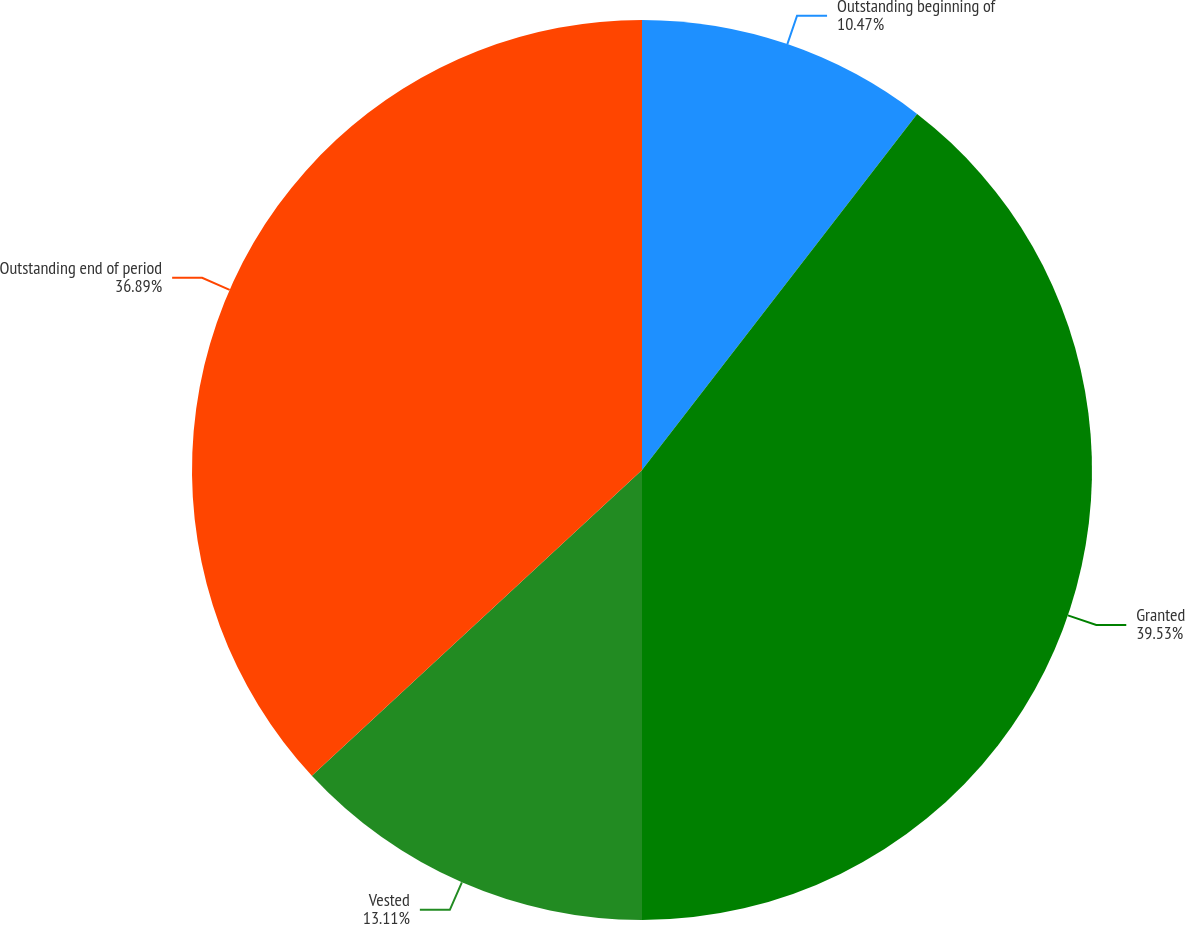<chart> <loc_0><loc_0><loc_500><loc_500><pie_chart><fcel>Outstanding beginning of<fcel>Granted<fcel>Vested<fcel>Outstanding end of period<nl><fcel>10.47%<fcel>39.53%<fcel>13.11%<fcel>36.89%<nl></chart> 